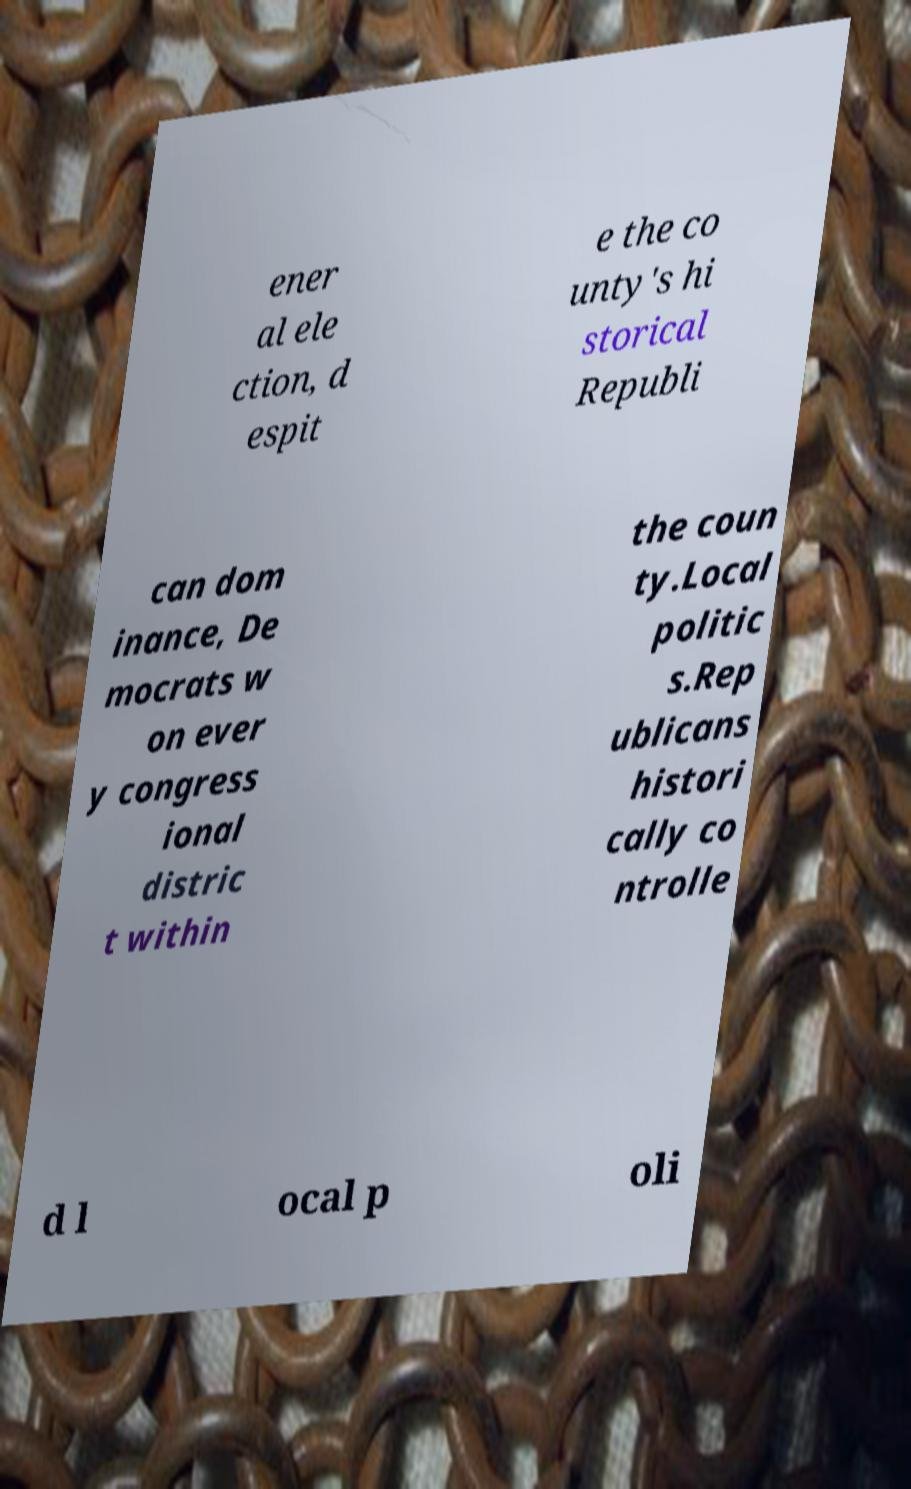Could you assist in decoding the text presented in this image and type it out clearly? ener al ele ction, d espit e the co unty's hi storical Republi can dom inance, De mocrats w on ever y congress ional distric t within the coun ty.Local politic s.Rep ublicans histori cally co ntrolle d l ocal p oli 